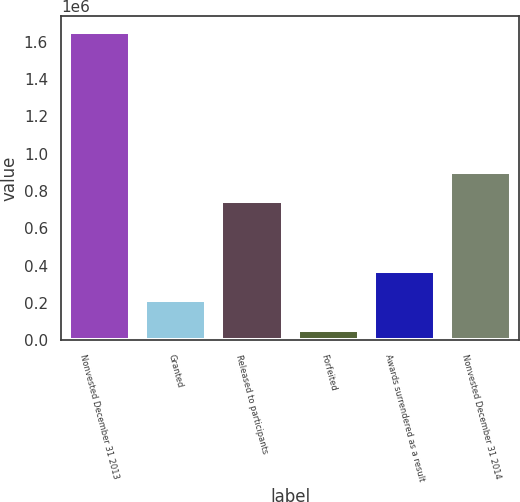<chart> <loc_0><loc_0><loc_500><loc_500><bar_chart><fcel>Nonvested December 31 2013<fcel>Granted<fcel>Released to participants<fcel>Forfeited<fcel>Awards surrendered as a result<fcel>Nonvested December 31 2014<nl><fcel>1.65214e+06<fcel>213749<fcel>743897<fcel>53927<fcel>373571<fcel>903719<nl></chart> 